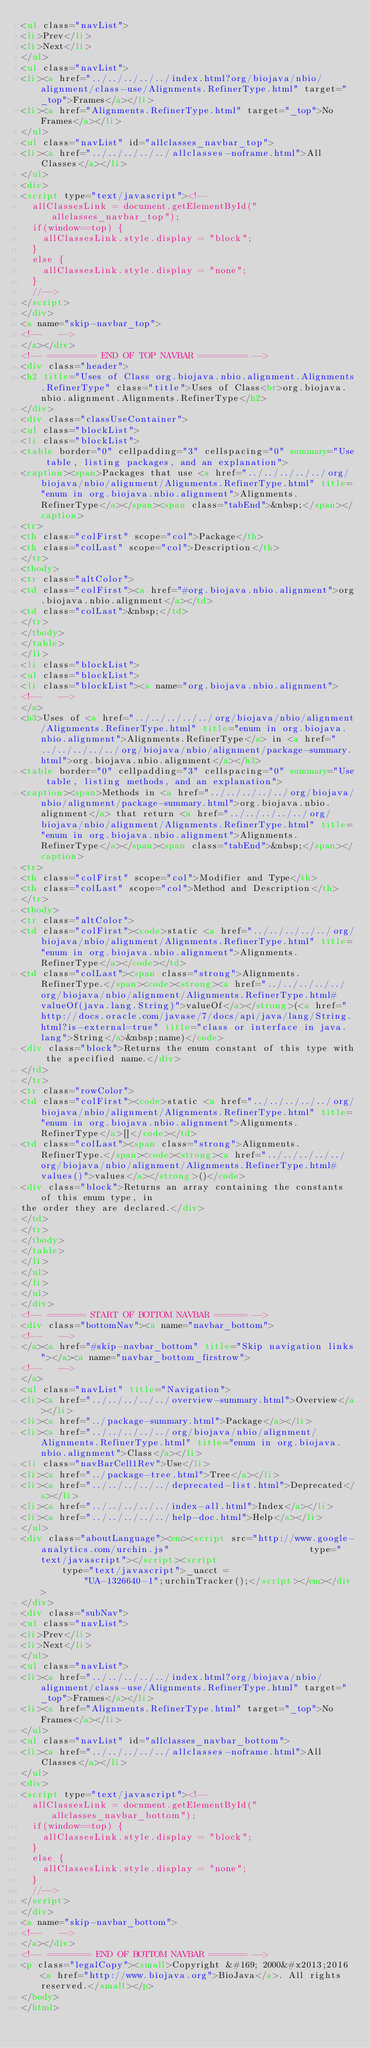Convert code to text. <code><loc_0><loc_0><loc_500><loc_500><_HTML_><ul class="navList">
<li>Prev</li>
<li>Next</li>
</ul>
<ul class="navList">
<li><a href="../../../../../index.html?org/biojava/nbio/alignment/class-use/Alignments.RefinerType.html" target="_top">Frames</a></li>
<li><a href="Alignments.RefinerType.html" target="_top">No Frames</a></li>
</ul>
<ul class="navList" id="allclasses_navbar_top">
<li><a href="../../../../../allclasses-noframe.html">All Classes</a></li>
</ul>
<div>
<script type="text/javascript"><!--
  allClassesLink = document.getElementById("allclasses_navbar_top");
  if(window==top) {
    allClassesLink.style.display = "block";
  }
  else {
    allClassesLink.style.display = "none";
  }
  //-->
</script>
</div>
<a name="skip-navbar_top">
<!--   -->
</a></div>
<!-- ========= END OF TOP NAVBAR ========= -->
<div class="header">
<h2 title="Uses of Class org.biojava.nbio.alignment.Alignments.RefinerType" class="title">Uses of Class<br>org.biojava.nbio.alignment.Alignments.RefinerType</h2>
</div>
<div class="classUseContainer">
<ul class="blockList">
<li class="blockList">
<table border="0" cellpadding="3" cellspacing="0" summary="Use table, listing packages, and an explanation">
<caption><span>Packages that use <a href="../../../../../org/biojava/nbio/alignment/Alignments.RefinerType.html" title="enum in org.biojava.nbio.alignment">Alignments.RefinerType</a></span><span class="tabEnd">&nbsp;</span></caption>
<tr>
<th class="colFirst" scope="col">Package</th>
<th class="colLast" scope="col">Description</th>
</tr>
<tbody>
<tr class="altColor">
<td class="colFirst"><a href="#org.biojava.nbio.alignment">org.biojava.nbio.alignment</a></td>
<td class="colLast">&nbsp;</td>
</tr>
</tbody>
</table>
</li>
<li class="blockList">
<ul class="blockList">
<li class="blockList"><a name="org.biojava.nbio.alignment">
<!--   -->
</a>
<h3>Uses of <a href="../../../../../org/biojava/nbio/alignment/Alignments.RefinerType.html" title="enum in org.biojava.nbio.alignment">Alignments.RefinerType</a> in <a href="../../../../../org/biojava/nbio/alignment/package-summary.html">org.biojava.nbio.alignment</a></h3>
<table border="0" cellpadding="3" cellspacing="0" summary="Use table, listing methods, and an explanation">
<caption><span>Methods in <a href="../../../../../org/biojava/nbio/alignment/package-summary.html">org.biojava.nbio.alignment</a> that return <a href="../../../../../org/biojava/nbio/alignment/Alignments.RefinerType.html" title="enum in org.biojava.nbio.alignment">Alignments.RefinerType</a></span><span class="tabEnd">&nbsp;</span></caption>
<tr>
<th class="colFirst" scope="col">Modifier and Type</th>
<th class="colLast" scope="col">Method and Description</th>
</tr>
<tbody>
<tr class="altColor">
<td class="colFirst"><code>static <a href="../../../../../org/biojava/nbio/alignment/Alignments.RefinerType.html" title="enum in org.biojava.nbio.alignment">Alignments.RefinerType</a></code></td>
<td class="colLast"><span class="strong">Alignments.RefinerType.</span><code><strong><a href="../../../../../org/biojava/nbio/alignment/Alignments.RefinerType.html#valueOf(java.lang.String)">valueOf</a></strong>(<a href="http://docs.oracle.com/javase/7/docs/api/java/lang/String.html?is-external=true" title="class or interface in java.lang">String</a>&nbsp;name)</code>
<div class="block">Returns the enum constant of this type with the specified name.</div>
</td>
</tr>
<tr class="rowColor">
<td class="colFirst"><code>static <a href="../../../../../org/biojava/nbio/alignment/Alignments.RefinerType.html" title="enum in org.biojava.nbio.alignment">Alignments.RefinerType</a>[]</code></td>
<td class="colLast"><span class="strong">Alignments.RefinerType.</span><code><strong><a href="../../../../../org/biojava/nbio/alignment/Alignments.RefinerType.html#values()">values</a></strong>()</code>
<div class="block">Returns an array containing the constants of this enum type, in
the order they are declared.</div>
</td>
</tr>
</tbody>
</table>
</li>
</ul>
</li>
</ul>
</div>
<!-- ======= START OF BOTTOM NAVBAR ====== -->
<div class="bottomNav"><a name="navbar_bottom">
<!--   -->
</a><a href="#skip-navbar_bottom" title="Skip navigation links"></a><a name="navbar_bottom_firstrow">
<!--   -->
</a>
<ul class="navList" title="Navigation">
<li><a href="../../../../../overview-summary.html">Overview</a></li>
<li><a href="../package-summary.html">Package</a></li>
<li><a href="../../../../../org/biojava/nbio/alignment/Alignments.RefinerType.html" title="enum in org.biojava.nbio.alignment">Class</a></li>
<li class="navBarCell1Rev">Use</li>
<li><a href="../package-tree.html">Tree</a></li>
<li><a href="../../../../../deprecated-list.html">Deprecated</a></li>
<li><a href="../../../../../index-all.html">Index</a></li>
<li><a href="../../../../../help-doc.html">Help</a></li>
</ul>
<div class="aboutLanguage"><em><script src="http://www.google-analytics.com/urchin.js" 							type="text/javascript"></script><script 							type="text/javascript">_uacct = 							"UA-1326640-1";urchinTracker();</script></em></div>
</div>
<div class="subNav">
<ul class="navList">
<li>Prev</li>
<li>Next</li>
</ul>
<ul class="navList">
<li><a href="../../../../../index.html?org/biojava/nbio/alignment/class-use/Alignments.RefinerType.html" target="_top">Frames</a></li>
<li><a href="Alignments.RefinerType.html" target="_top">No Frames</a></li>
</ul>
<ul class="navList" id="allclasses_navbar_bottom">
<li><a href="../../../../../allclasses-noframe.html">All Classes</a></li>
</ul>
<div>
<script type="text/javascript"><!--
  allClassesLink = document.getElementById("allclasses_navbar_bottom");
  if(window==top) {
    allClassesLink.style.display = "block";
  }
  else {
    allClassesLink.style.display = "none";
  }
  //-->
</script>
</div>
<a name="skip-navbar_bottom">
<!--   -->
</a></div>
<!-- ======== END OF BOTTOM NAVBAR ======= -->
<p class="legalCopy"><small>Copyright &#169; 2000&#x2013;2016 <a href="http://www.biojava.org">BioJava</a>. All rights reserved.</small></p>
</body>
</html>
</code> 